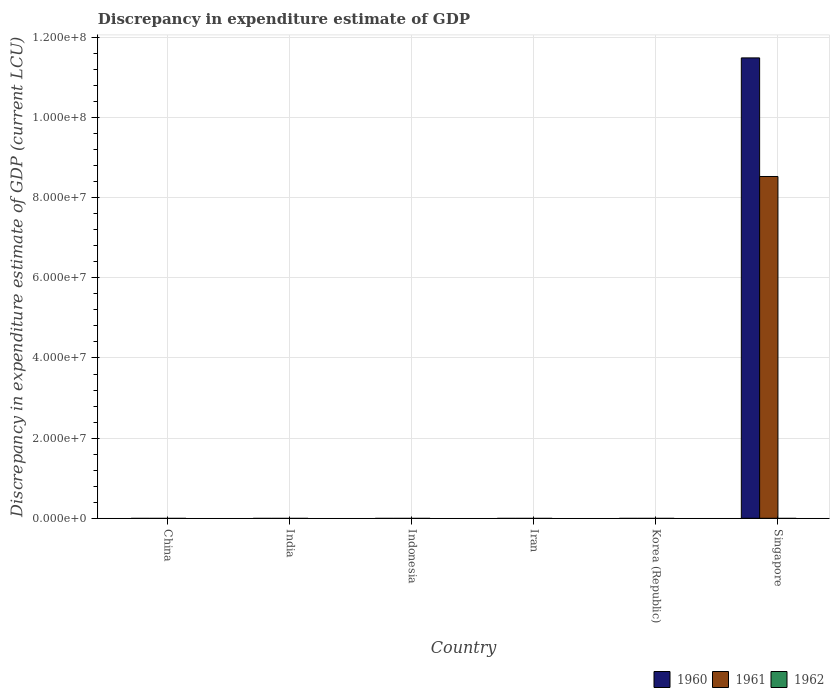How many bars are there on the 2nd tick from the left?
Offer a very short reply. 0. How many bars are there on the 4th tick from the right?
Keep it short and to the point. 0. What is the label of the 6th group of bars from the left?
Offer a very short reply. Singapore. What is the discrepancy in expenditure estimate of GDP in 1962 in India?
Provide a succinct answer. 0. Across all countries, what is the maximum discrepancy in expenditure estimate of GDP in 1961?
Offer a very short reply. 8.53e+07. Across all countries, what is the minimum discrepancy in expenditure estimate of GDP in 1961?
Offer a terse response. 0. In which country was the discrepancy in expenditure estimate of GDP in 1961 maximum?
Keep it short and to the point. Singapore. What is the total discrepancy in expenditure estimate of GDP in 1961 in the graph?
Offer a very short reply. 8.53e+07. What is the difference between the discrepancy in expenditure estimate of GDP in 1961 in China and the discrepancy in expenditure estimate of GDP in 1960 in Singapore?
Make the answer very short. -1.15e+08. What is the average discrepancy in expenditure estimate of GDP in 1961 per country?
Your response must be concise. 1.42e+07. What is the difference between the discrepancy in expenditure estimate of GDP of/in 1960 and discrepancy in expenditure estimate of GDP of/in 1961 in Singapore?
Provide a short and direct response. 2.96e+07. What is the difference between the highest and the lowest discrepancy in expenditure estimate of GDP in 1960?
Offer a terse response. 1.15e+08. Are all the bars in the graph horizontal?
Keep it short and to the point. No. How many countries are there in the graph?
Keep it short and to the point. 6. Are the values on the major ticks of Y-axis written in scientific E-notation?
Provide a succinct answer. Yes. Does the graph contain grids?
Provide a succinct answer. Yes. Where does the legend appear in the graph?
Make the answer very short. Bottom right. How many legend labels are there?
Your response must be concise. 3. How are the legend labels stacked?
Ensure brevity in your answer.  Horizontal. What is the title of the graph?
Ensure brevity in your answer.  Discrepancy in expenditure estimate of GDP. What is the label or title of the X-axis?
Provide a short and direct response. Country. What is the label or title of the Y-axis?
Ensure brevity in your answer.  Discrepancy in expenditure estimate of GDP (current LCU). What is the Discrepancy in expenditure estimate of GDP (current LCU) in 1960 in China?
Your response must be concise. 0. What is the Discrepancy in expenditure estimate of GDP (current LCU) in 1961 in China?
Your answer should be very brief. 0. What is the Discrepancy in expenditure estimate of GDP (current LCU) in 1960 in India?
Your answer should be compact. 0. What is the Discrepancy in expenditure estimate of GDP (current LCU) of 1960 in Indonesia?
Offer a terse response. 0. What is the Discrepancy in expenditure estimate of GDP (current LCU) of 1960 in Korea (Republic)?
Offer a terse response. 0. What is the Discrepancy in expenditure estimate of GDP (current LCU) in 1961 in Korea (Republic)?
Give a very brief answer. 0. What is the Discrepancy in expenditure estimate of GDP (current LCU) in 1960 in Singapore?
Keep it short and to the point. 1.15e+08. What is the Discrepancy in expenditure estimate of GDP (current LCU) in 1961 in Singapore?
Keep it short and to the point. 8.53e+07. Across all countries, what is the maximum Discrepancy in expenditure estimate of GDP (current LCU) of 1960?
Ensure brevity in your answer.  1.15e+08. Across all countries, what is the maximum Discrepancy in expenditure estimate of GDP (current LCU) of 1961?
Your response must be concise. 8.53e+07. Across all countries, what is the minimum Discrepancy in expenditure estimate of GDP (current LCU) of 1961?
Provide a short and direct response. 0. What is the total Discrepancy in expenditure estimate of GDP (current LCU) of 1960 in the graph?
Offer a very short reply. 1.15e+08. What is the total Discrepancy in expenditure estimate of GDP (current LCU) in 1961 in the graph?
Offer a terse response. 8.53e+07. What is the total Discrepancy in expenditure estimate of GDP (current LCU) of 1962 in the graph?
Provide a short and direct response. 0. What is the average Discrepancy in expenditure estimate of GDP (current LCU) of 1960 per country?
Your response must be concise. 1.92e+07. What is the average Discrepancy in expenditure estimate of GDP (current LCU) of 1961 per country?
Give a very brief answer. 1.42e+07. What is the average Discrepancy in expenditure estimate of GDP (current LCU) in 1962 per country?
Keep it short and to the point. 0. What is the difference between the Discrepancy in expenditure estimate of GDP (current LCU) of 1960 and Discrepancy in expenditure estimate of GDP (current LCU) of 1961 in Singapore?
Ensure brevity in your answer.  2.96e+07. What is the difference between the highest and the lowest Discrepancy in expenditure estimate of GDP (current LCU) of 1960?
Provide a short and direct response. 1.15e+08. What is the difference between the highest and the lowest Discrepancy in expenditure estimate of GDP (current LCU) of 1961?
Your response must be concise. 8.53e+07. 